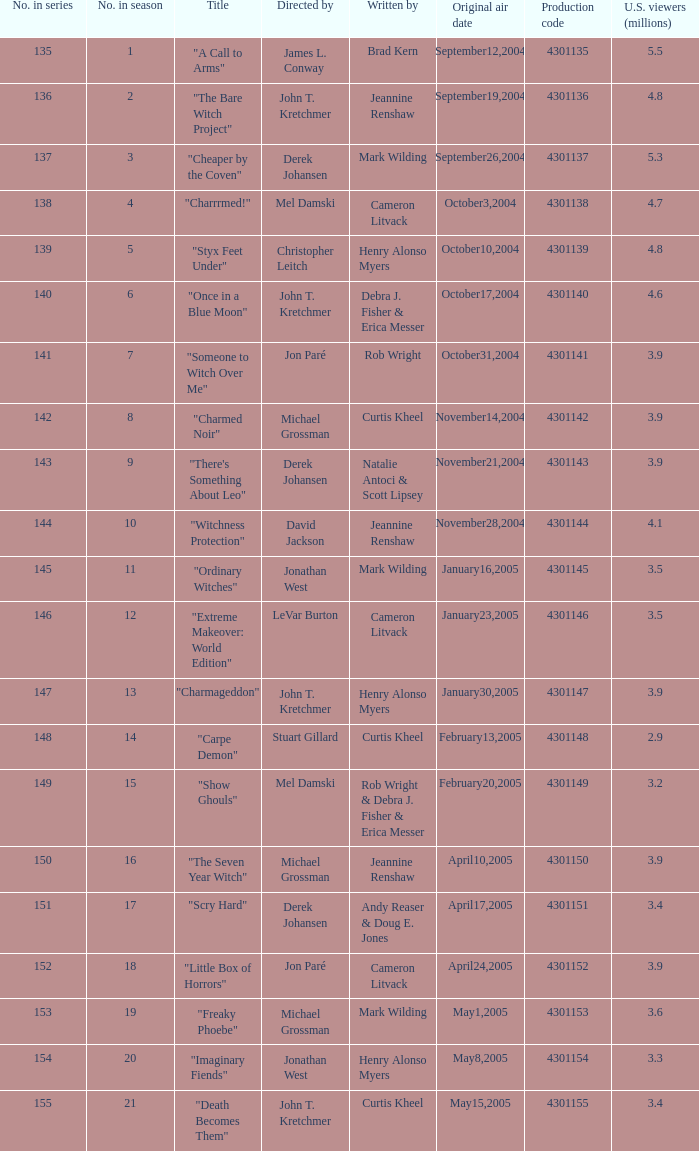What was the name of the episode that got 3.3 (millions) of u.s viewers? "Imaginary Fiends". 